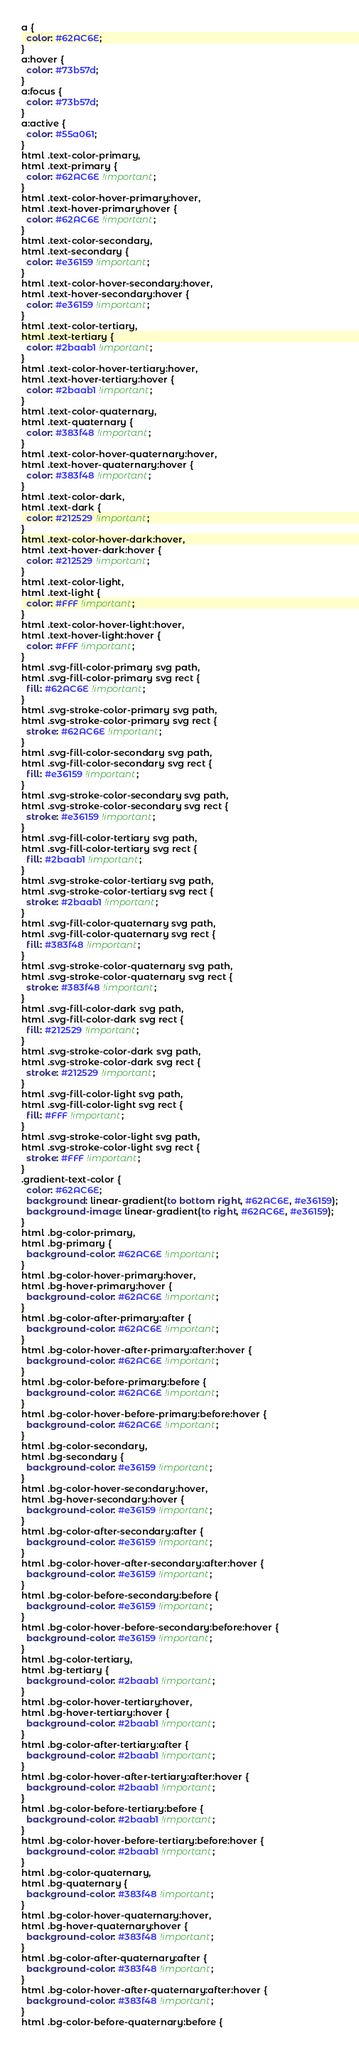Convert code to text. <code><loc_0><loc_0><loc_500><loc_500><_CSS_>a {
  color: #62AC6E;
}
a:hover {
  color: #73b57d;
}
a:focus {
  color: #73b57d;
}
a:active {
  color: #55a061;
}
html .text-color-primary,
html .text-primary {
  color: #62AC6E !important;
}
html .text-color-hover-primary:hover,
html .text-hover-primary:hover {
  color: #62AC6E !important;
}
html .text-color-secondary,
html .text-secondary {
  color: #e36159 !important;
}
html .text-color-hover-secondary:hover,
html .text-hover-secondary:hover {
  color: #e36159 !important;
}
html .text-color-tertiary,
html .text-tertiary {
  color: #2baab1 !important;
}
html .text-color-hover-tertiary:hover,
html .text-hover-tertiary:hover {
  color: #2baab1 !important;
}
html .text-color-quaternary,
html .text-quaternary {
  color: #383f48 !important;
}
html .text-color-hover-quaternary:hover,
html .text-hover-quaternary:hover {
  color: #383f48 !important;
}
html .text-color-dark,
html .text-dark {
  color: #212529 !important;
}
html .text-color-hover-dark:hover,
html .text-hover-dark:hover {
  color: #212529 !important;
}
html .text-color-light,
html .text-light {
  color: #FFF !important;
}
html .text-color-hover-light:hover,
html .text-hover-light:hover {
  color: #FFF !important;
}
html .svg-fill-color-primary svg path,
html .svg-fill-color-primary svg rect {
  fill: #62AC6E !important;
}
html .svg-stroke-color-primary svg path,
html .svg-stroke-color-primary svg rect {
  stroke: #62AC6E !important;
}
html .svg-fill-color-secondary svg path,
html .svg-fill-color-secondary svg rect {
  fill: #e36159 !important;
}
html .svg-stroke-color-secondary svg path,
html .svg-stroke-color-secondary svg rect {
  stroke: #e36159 !important;
}
html .svg-fill-color-tertiary svg path,
html .svg-fill-color-tertiary svg rect {
  fill: #2baab1 !important;
}
html .svg-stroke-color-tertiary svg path,
html .svg-stroke-color-tertiary svg rect {
  stroke: #2baab1 !important;
}
html .svg-fill-color-quaternary svg path,
html .svg-fill-color-quaternary svg rect {
  fill: #383f48 !important;
}
html .svg-stroke-color-quaternary svg path,
html .svg-stroke-color-quaternary svg rect {
  stroke: #383f48 !important;
}
html .svg-fill-color-dark svg path,
html .svg-fill-color-dark svg rect {
  fill: #212529 !important;
}
html .svg-stroke-color-dark svg path,
html .svg-stroke-color-dark svg rect {
  stroke: #212529 !important;
}
html .svg-fill-color-light svg path,
html .svg-fill-color-light svg rect {
  fill: #FFF !important;
}
html .svg-stroke-color-light svg path,
html .svg-stroke-color-light svg rect {
  stroke: #FFF !important;
}
.gradient-text-color {
  color: #62AC6E;
  background: linear-gradient(to bottom right, #62AC6E, #e36159);
  background-image: linear-gradient(to right, #62AC6E, #e36159);
}
html .bg-color-primary,
html .bg-primary {
  background-color: #62AC6E !important;
}
html .bg-color-hover-primary:hover,
html .bg-hover-primary:hover {
  background-color: #62AC6E !important;
}
html .bg-color-after-primary:after {
  background-color: #62AC6E !important;
}
html .bg-color-hover-after-primary:after:hover {
  background-color: #62AC6E !important;
}
html .bg-color-before-primary:before {
  background-color: #62AC6E !important;
}
html .bg-color-hover-before-primary:before:hover {
  background-color: #62AC6E !important;
}
html .bg-color-secondary,
html .bg-secondary {
  background-color: #e36159 !important;
}
html .bg-color-hover-secondary:hover,
html .bg-hover-secondary:hover {
  background-color: #e36159 !important;
}
html .bg-color-after-secondary:after {
  background-color: #e36159 !important;
}
html .bg-color-hover-after-secondary:after:hover {
  background-color: #e36159 !important;
}
html .bg-color-before-secondary:before {
  background-color: #e36159 !important;
}
html .bg-color-hover-before-secondary:before:hover {
  background-color: #e36159 !important;
}
html .bg-color-tertiary,
html .bg-tertiary {
  background-color: #2baab1 !important;
}
html .bg-color-hover-tertiary:hover,
html .bg-hover-tertiary:hover {
  background-color: #2baab1 !important;
}
html .bg-color-after-tertiary:after {
  background-color: #2baab1 !important;
}
html .bg-color-hover-after-tertiary:after:hover {
  background-color: #2baab1 !important;
}
html .bg-color-before-tertiary:before {
  background-color: #2baab1 !important;
}
html .bg-color-hover-before-tertiary:before:hover {
  background-color: #2baab1 !important;
}
html .bg-color-quaternary,
html .bg-quaternary {
  background-color: #383f48 !important;
}
html .bg-color-hover-quaternary:hover,
html .bg-hover-quaternary:hover {
  background-color: #383f48 !important;
}
html .bg-color-after-quaternary:after {
  background-color: #383f48 !important;
}
html .bg-color-hover-after-quaternary:after:hover {
  background-color: #383f48 !important;
}
html .bg-color-before-quaternary:before {</code> 